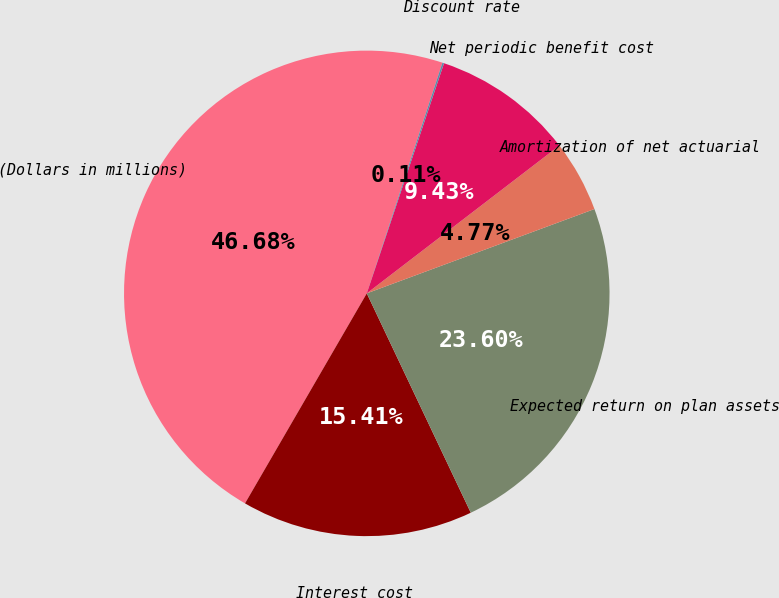Convert chart to OTSL. <chart><loc_0><loc_0><loc_500><loc_500><pie_chart><fcel>(Dollars in millions)<fcel>Interest cost<fcel>Expected return on plan assets<fcel>Amortization of net actuarial<fcel>Net periodic benefit cost<fcel>Discount rate<nl><fcel>46.68%<fcel>15.41%<fcel>23.6%<fcel>4.77%<fcel>9.43%<fcel>0.11%<nl></chart> 